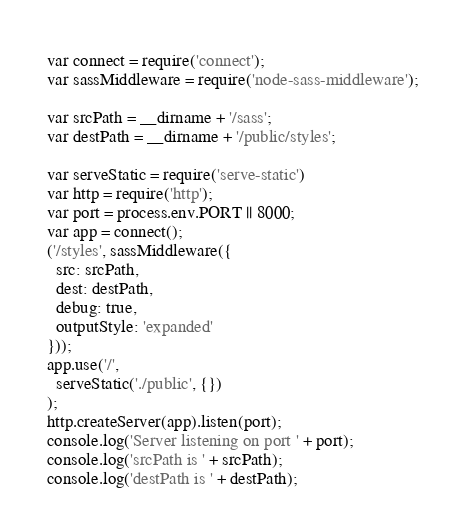Convert code to text. <code><loc_0><loc_0><loc_500><loc_500><_JavaScript_>var connect = require('connect');
var sassMiddleware = require('node-sass-middleware');

var srcPath = __dirname + '/sass';
var destPath = __dirname + '/public/styles';

var serveStatic = require('serve-static')
var http = require('http');
var port = process.env.PORT || 8000;
var app = connect();
('/styles', sassMiddleware({
  src: srcPath,
  dest: destPath,
  debug: true,
  outputStyle: 'expanded'
}));
app.use('/',
  serveStatic('./public', {})
);
http.createServer(app).listen(port);
console.log('Server listening on port ' + port);
console.log('srcPath is ' + srcPath);
console.log('destPath is ' + destPath);
</code> 